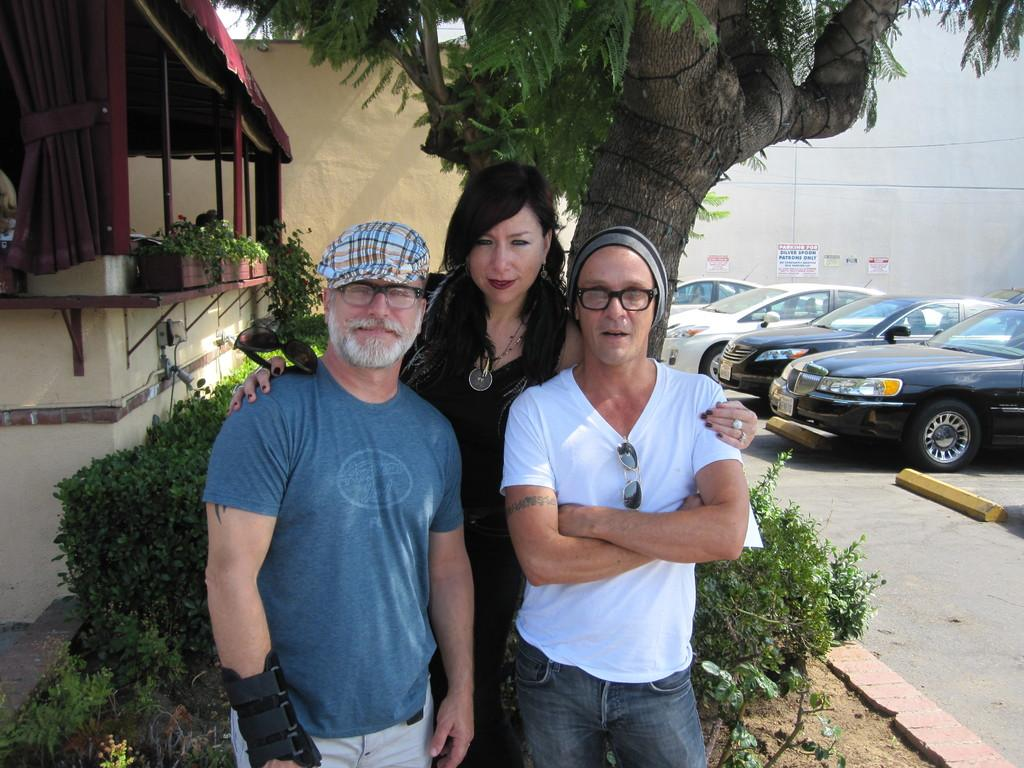What can be seen in the image in the image? There are people standing in the image. Can you describe the attire of some of the individuals? There are men wearing caps in the image. What is visible in the background of the image? There are cars parked on the road and a tree in the background of the image. Are there any plants present in the image? Yes, there are plants kept in a pot in the image. How does the respect for the tree in the image manifest itself? The image does not show any indication of respect for the tree; it simply depicts a tree in the background. Can you describe the twist in the image? There is no twist present in the image; it is a straightforward depiction of people, men wearing caps, parked cars, a tree, and plants in a pot. 